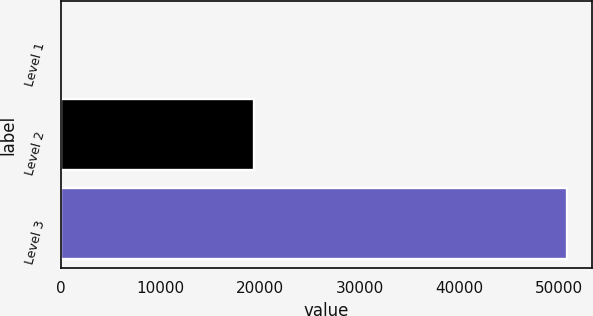<chart> <loc_0><loc_0><loc_500><loc_500><bar_chart><fcel>Level 1<fcel>Level 2<fcel>Level 3<nl><fcel>1.61<fcel>19416<fcel>50805<nl></chart> 